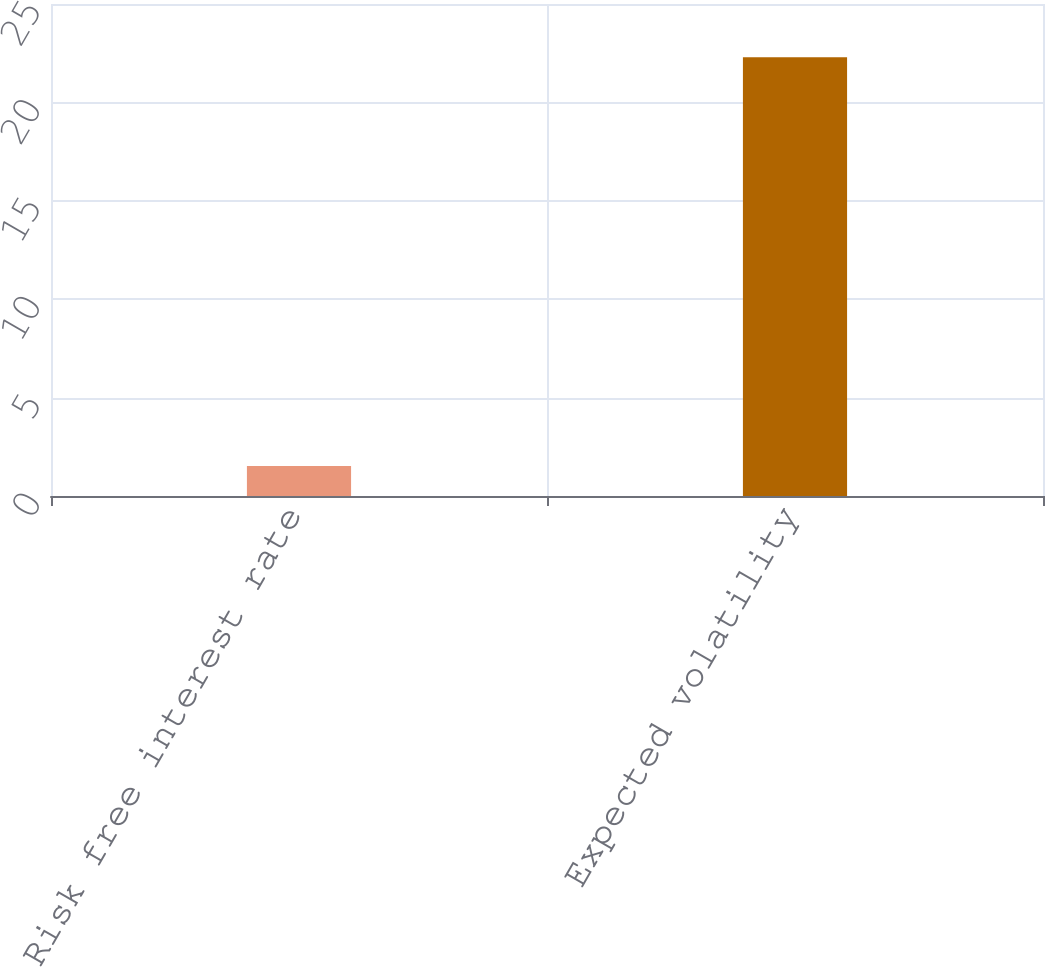Convert chart. <chart><loc_0><loc_0><loc_500><loc_500><bar_chart><fcel>Risk free interest rate<fcel>Expected volatility<nl><fcel>1.52<fcel>22.3<nl></chart> 